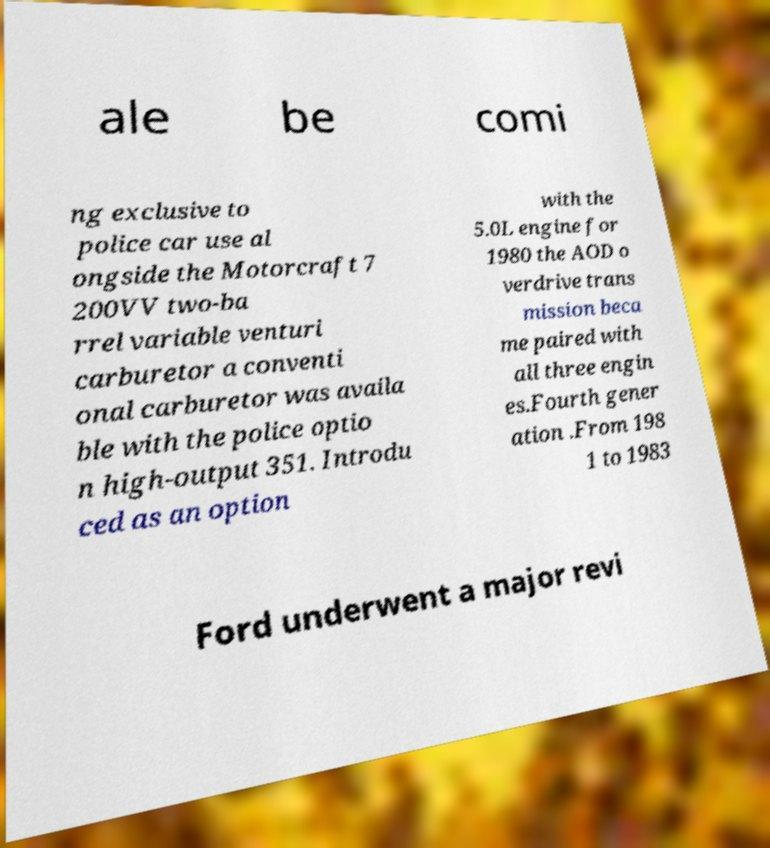Please identify and transcribe the text found in this image. ale be comi ng exclusive to police car use al ongside the Motorcraft 7 200VV two-ba rrel variable venturi carburetor a conventi onal carburetor was availa ble with the police optio n high-output 351. Introdu ced as an option with the 5.0L engine for 1980 the AOD o verdrive trans mission beca me paired with all three engin es.Fourth gener ation .From 198 1 to 1983 Ford underwent a major revi 